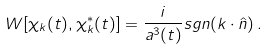<formula> <loc_0><loc_0><loc_500><loc_500>W [ \chi _ { k } ( t ) , \chi _ { k } ^ { \ast } ( t ) ] = \frac { i } { a ^ { 3 } ( t ) } s g n ( k \cdot \hat { n } ) \, .</formula> 